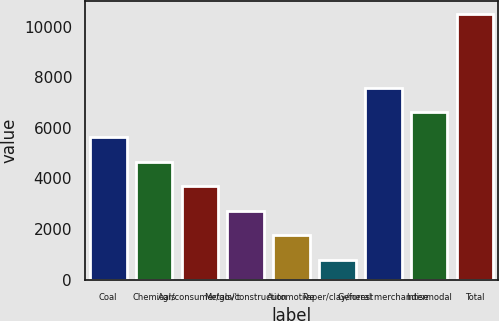Convert chart to OTSL. <chart><loc_0><loc_0><loc_500><loc_500><bar_chart><fcel>Coal<fcel>Chemicals<fcel>Agr/consumer/gov't<fcel>Metals/construction<fcel>Automotive<fcel>Paper/clay/forest<fcel>General merchandise<fcel>Intermodal<fcel>Total<nl><fcel>5641<fcel>4667<fcel>3693<fcel>2719<fcel>1745<fcel>771<fcel>7589<fcel>6615<fcel>10511<nl></chart> 